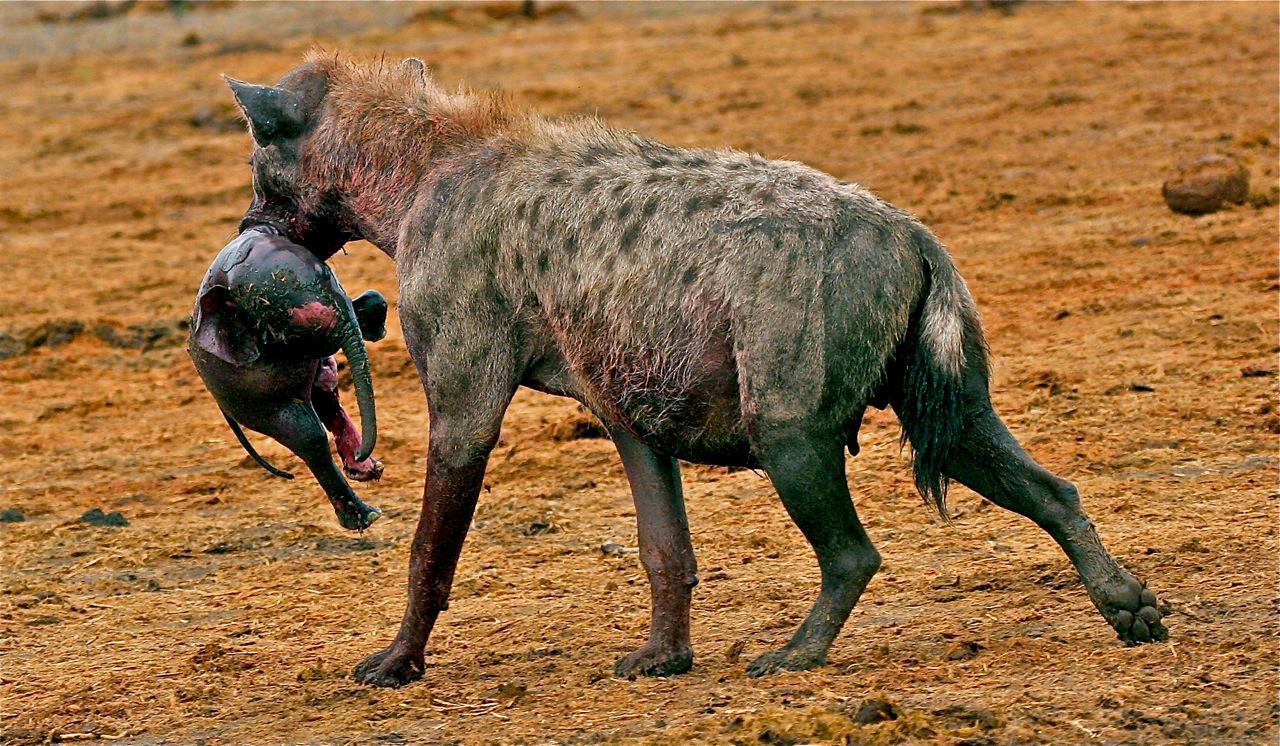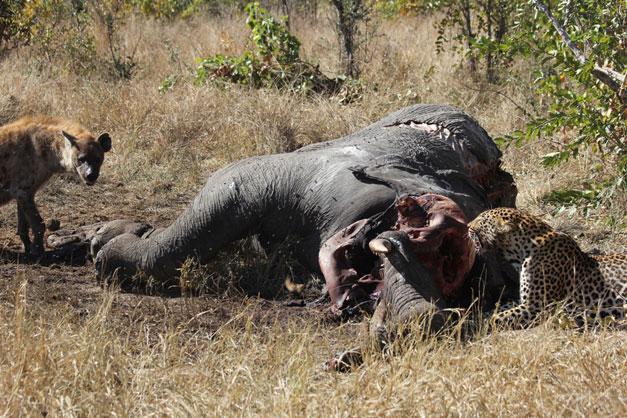The first image is the image on the left, the second image is the image on the right. Considering the images on both sides, is "Cheetahs are attacking an elephant on the ground in the image on the right." valid? Answer yes or no. Yes. The first image is the image on the left, the second image is the image on the right. Analyze the images presented: Is the assertion "Contains a picture with more than 1 Hyena." valid? Answer yes or no. Yes. 